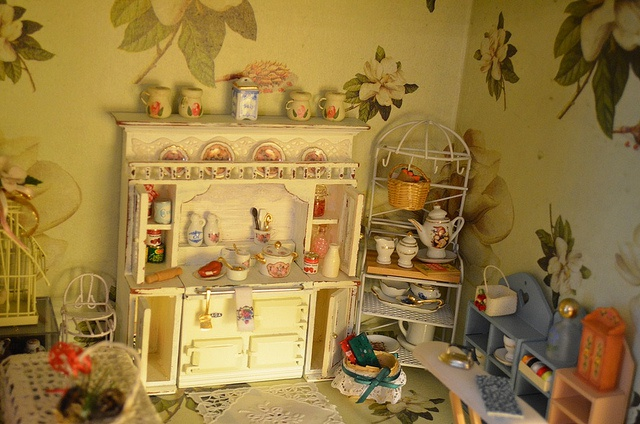Describe the objects in this image and their specific colors. I can see chair in maroon, olive, and tan tones, cup in maroon, tan, olive, and gray tones, cup in maroon, olive, and tan tones, vase in maroon, tan, and olive tones, and cup in maroon, tan, and olive tones in this image. 